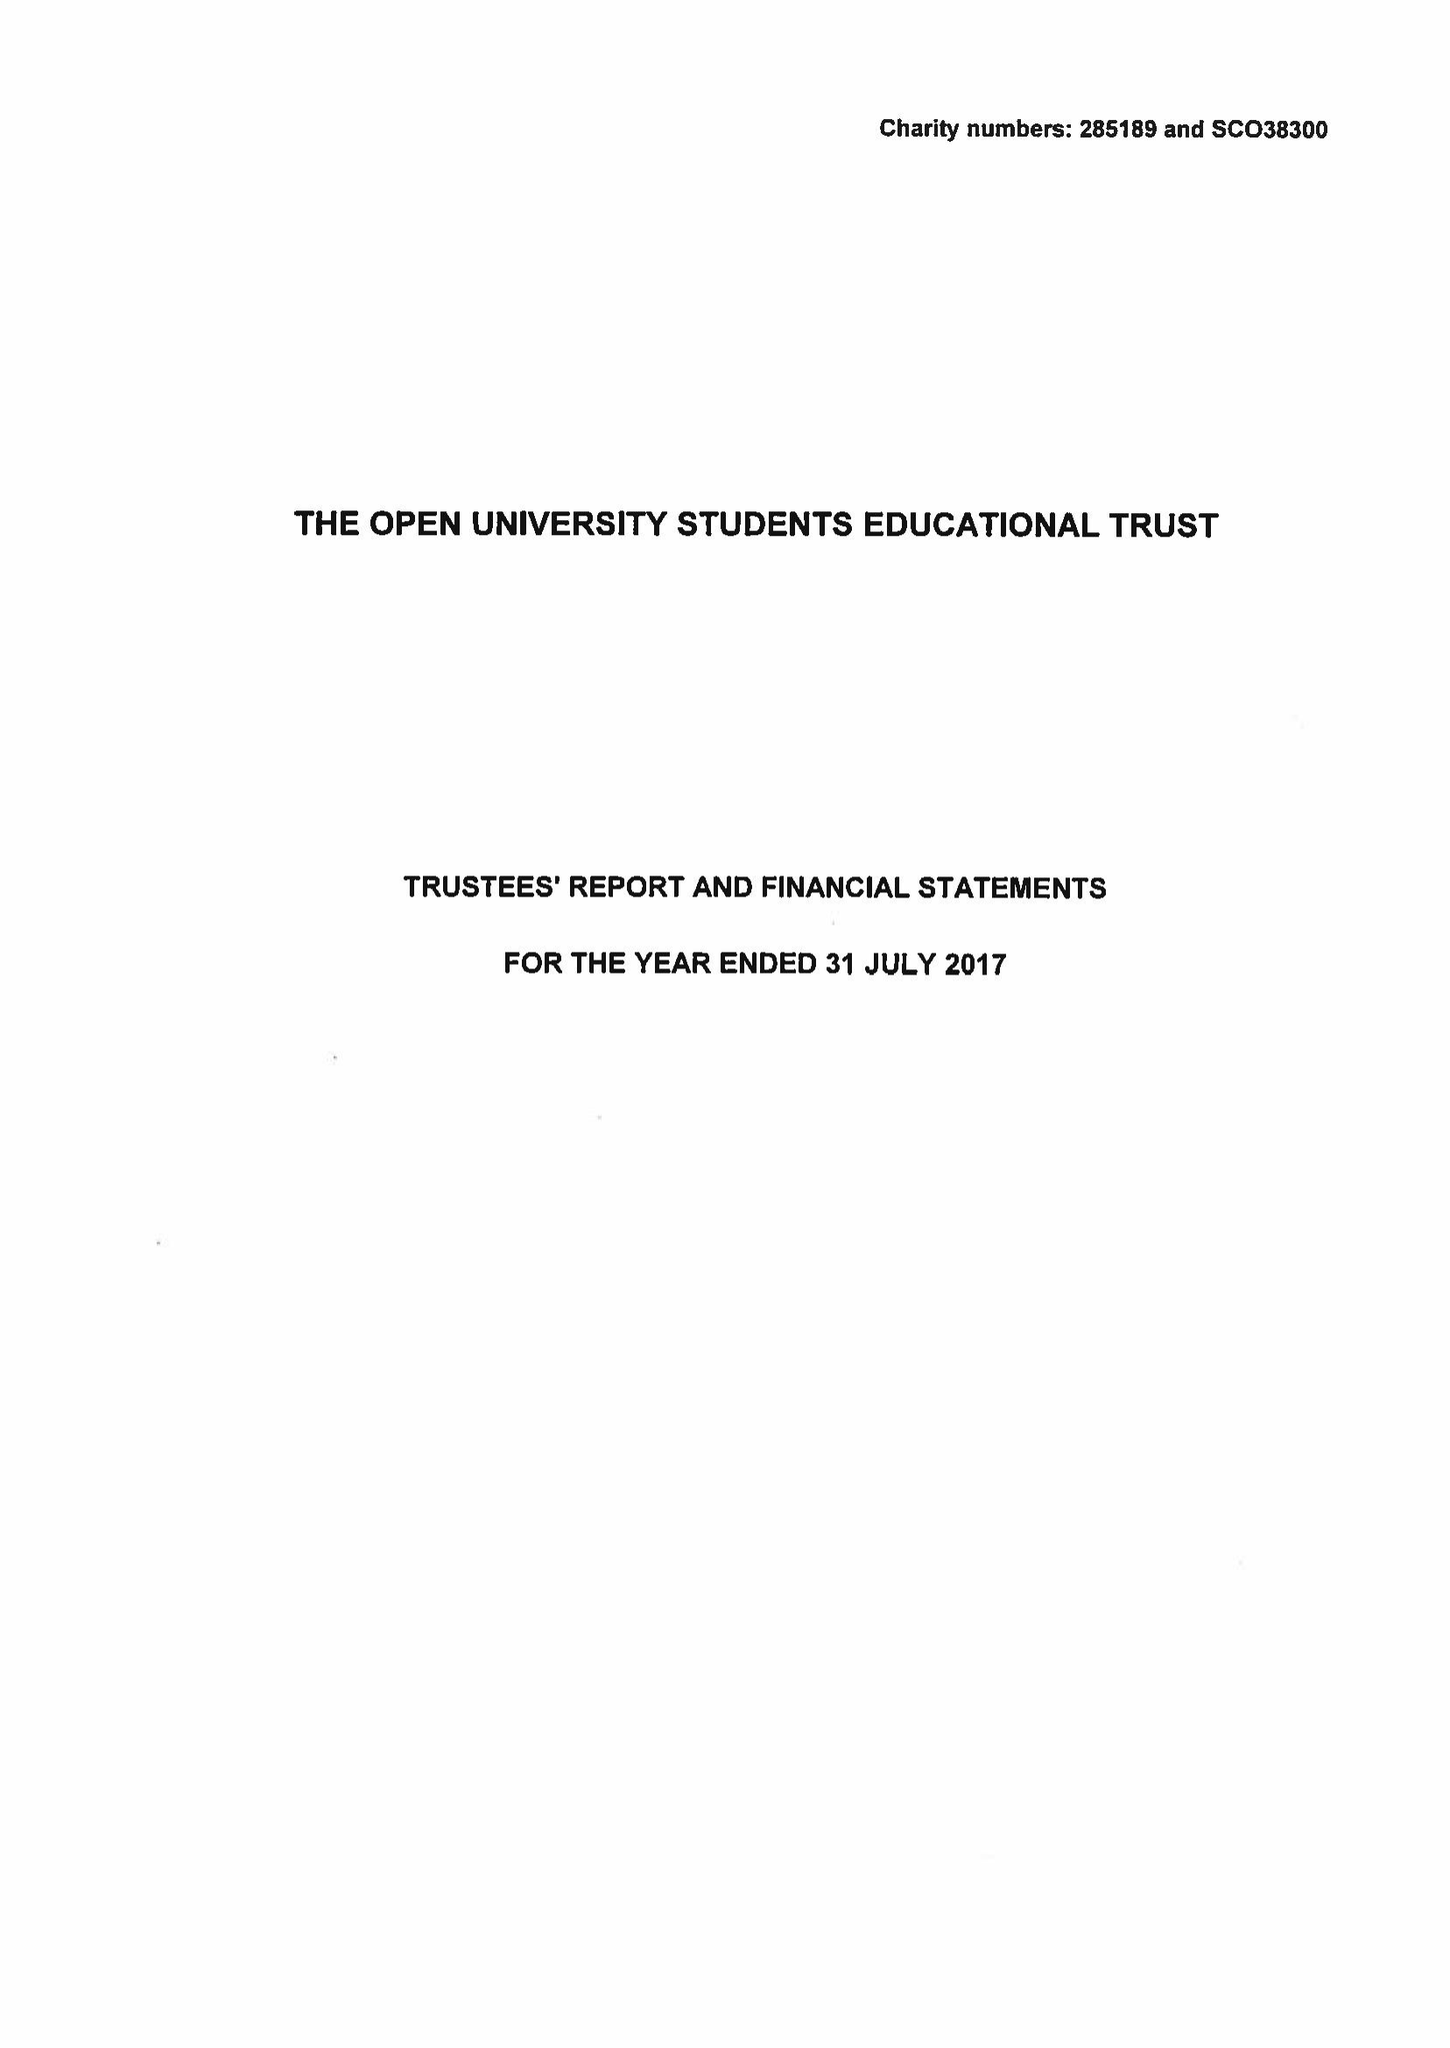What is the value for the address__post_town?
Answer the question using a single word or phrase. MILTON KEYNES 